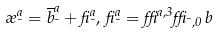<formula> <loc_0><loc_0><loc_500><loc_500>\rho _ { \mu } ^ { a } = \overline { b } ^ { a } _ { \mu } + \beta ^ { a } _ { \mu } , \, \beta ^ { a } _ { \mu } = \delta ^ { a , 3 } \delta _ { \mu , 0 } \, b</formula> 